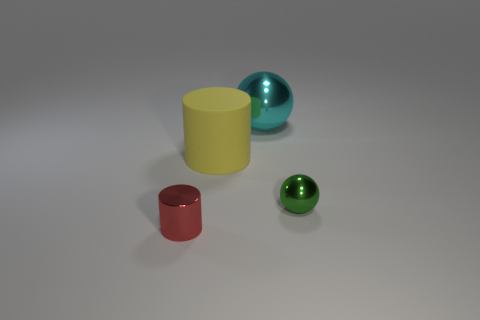Add 4 cyan metallic spheres. How many objects exist? 8 Add 1 yellow cylinders. How many yellow cylinders exist? 2 Subtract 0 brown cylinders. How many objects are left? 4 Subtract all big blue matte things. Subtract all big yellow rubber objects. How many objects are left? 3 Add 4 cyan objects. How many cyan objects are left? 5 